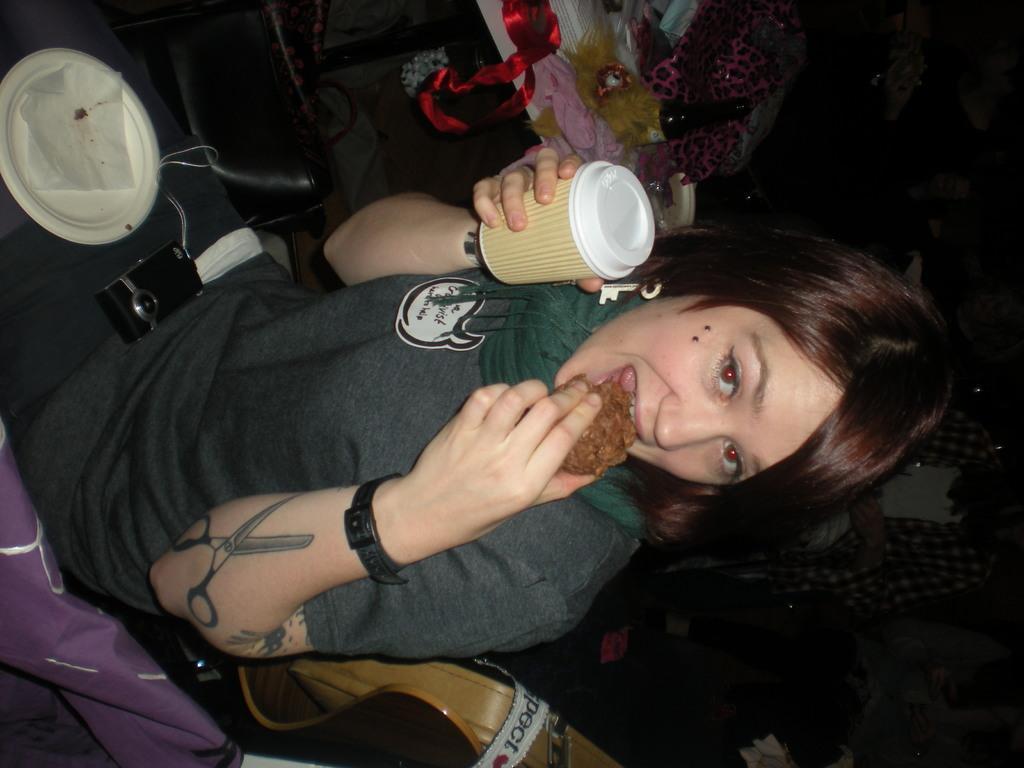Describe this image in one or two sentences. In the foreground of this picture we can see a person wearing T-shirt, scarf, sitting and holding a glass and eating a food item and we can see a white color platter and a camera is placed on the lap of a person. In the background, we can see there are some objects placed on the top of the table and we can see a person and some other objects in the background. 